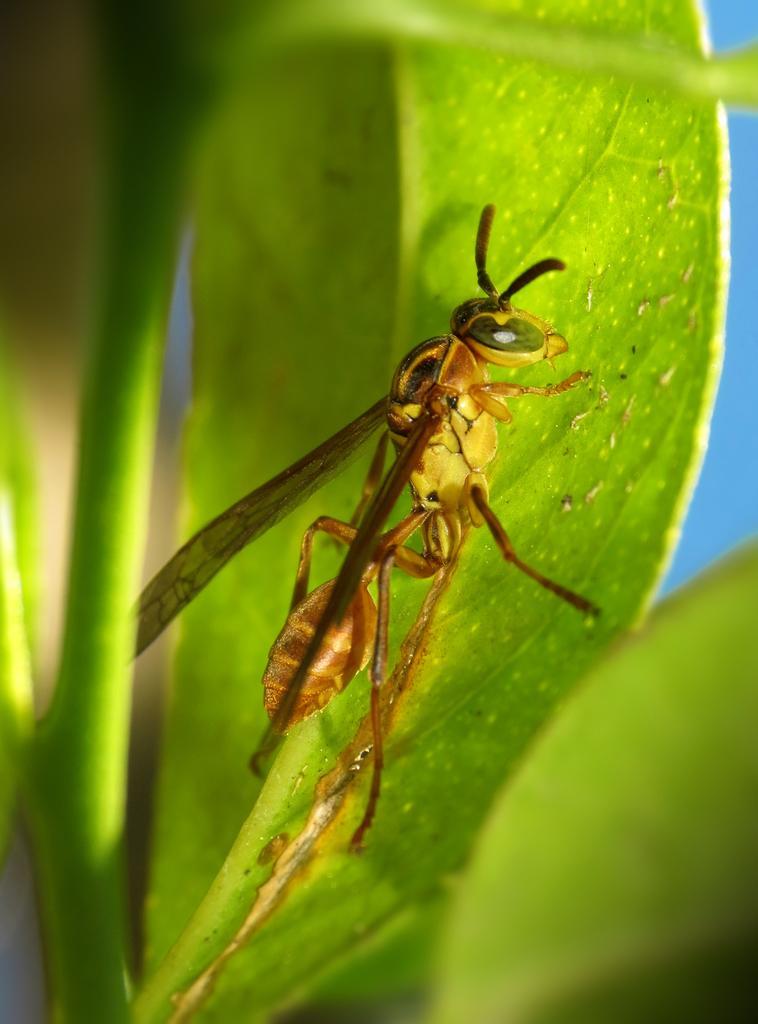Could you give a brief overview of what you see in this image? In this image, we can see an insect on the green leaf. Here we can see stems. Background there is a blur view. 